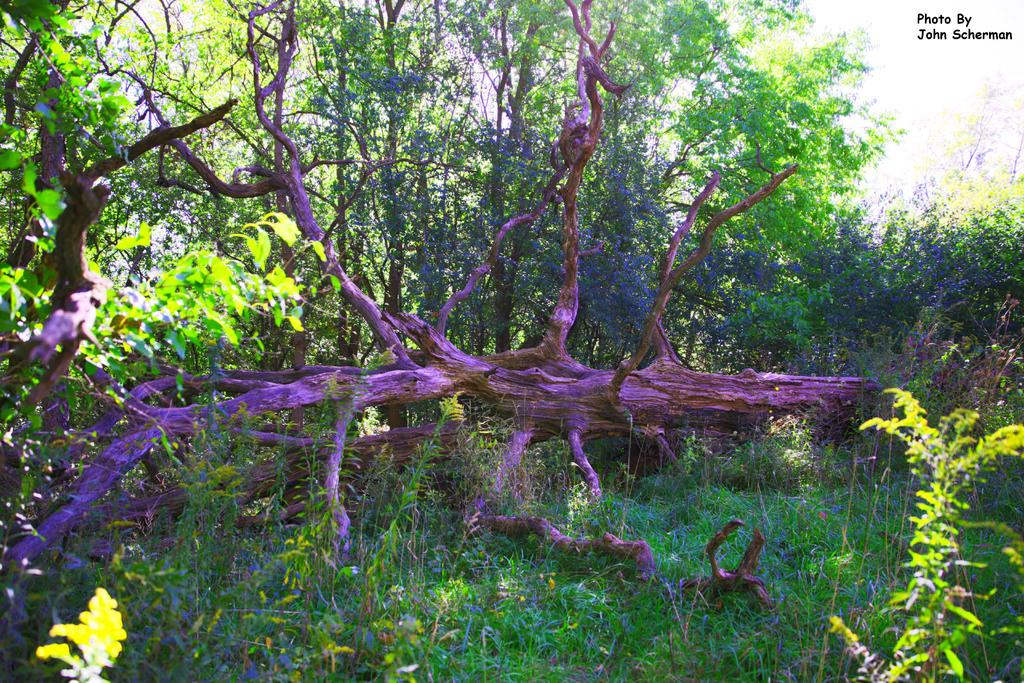What type of plants can be seen in the image? There are grass plants and other plants in the image. What else can be seen in the image besides plants? There is a tree branch in the image. How is the tree branch illuminated in the image? The tree branch has a blue color light focused on it. What can be seen in the background of the image? There are plants, trees, and the sky visible in the background of the image. What type of smoke can be seen coming from the frame in the image? There is no frame or smoke present in the image. What type of crime is being committed in the image? There is no crime or criminal activity depicted in the image. 